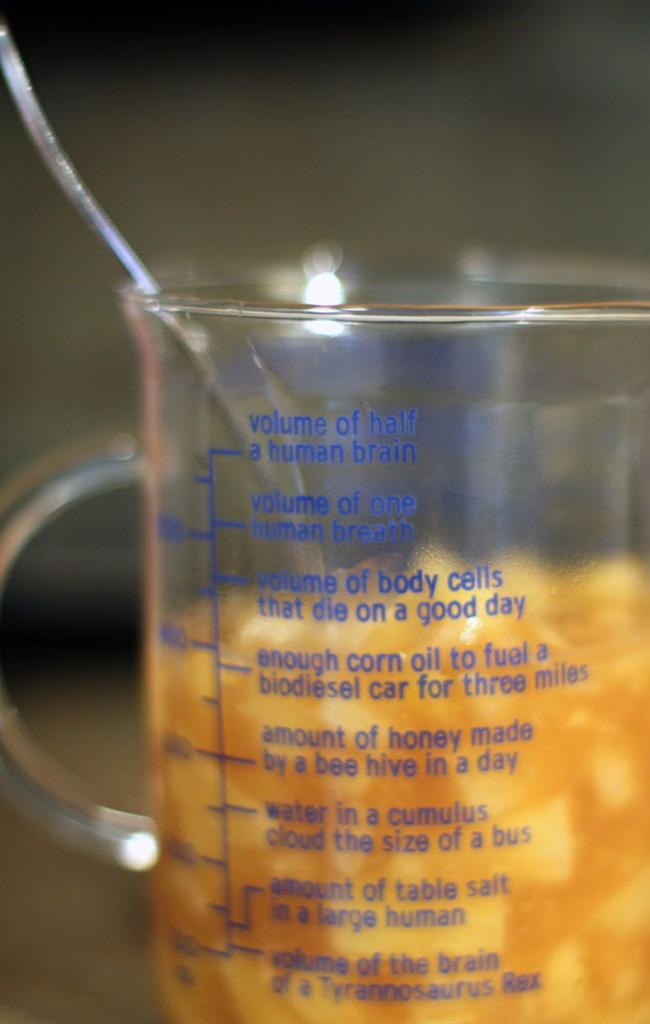<image>
Give a short and clear explanation of the subsequent image. A spoon is in a measuring cup and is filled to the words volume of body cells that die on a good day. 